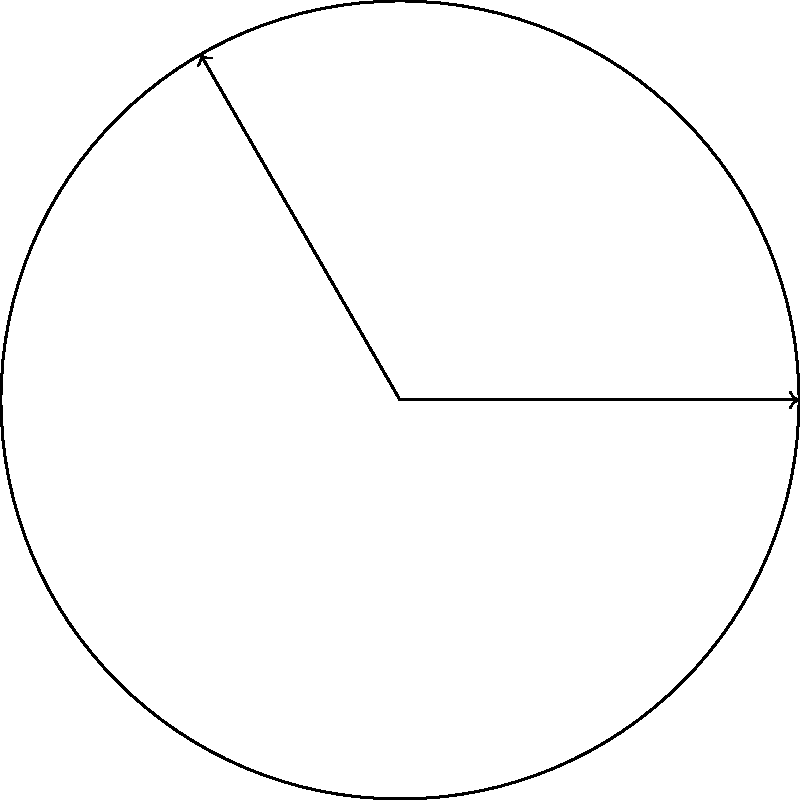You're designing a new circular irrigation system for your field that borders the South Downs Way. The system rotates around a central point and needs to cover the entire circular area. If the radius of the field is 50 meters and the irrigation arm makes a complete rotation in 2 hours, what is the angle (in degrees) through which the arm rotates in 15 minutes? Let's approach this step-by-step:

1) First, we need to understand the relationship between time and rotation:
   - A complete rotation (360°) takes 2 hours
   - We want to find the rotation in 15 minutes

2) Let's convert everything to minutes:
   - 2 hours = 120 minutes
   - 360° in 120 minutes

3) Now, we can set up a proportion:
   $$\frac{360°}{120 \text{ minutes}} = \frac{x°}{15 \text{ minutes}}$$

4) Cross multiply:
   $$360 \cdot 15 = 120x$$

5) Solve for $x$:
   $$5400 = 120x$$
   $$x = \frac{5400}{120} = 45$$

Therefore, in 15 minutes, the irrigation arm rotates through an angle of 45°.
Answer: 45° 